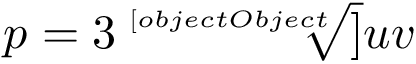Convert formula to latex. <formula><loc_0><loc_0><loc_500><loc_500>p = 3 { \sqrt { [ } [ o b j e c t O b j e c t ] ] { u v } }</formula> 